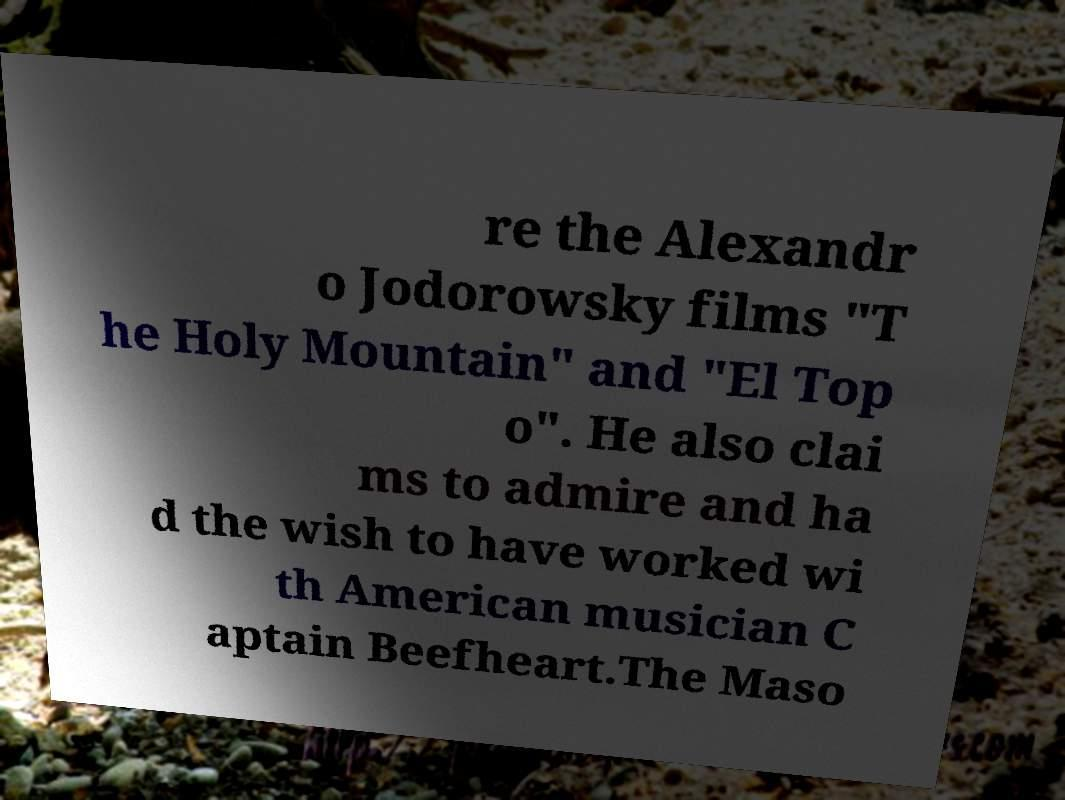Could you assist in decoding the text presented in this image and type it out clearly? re the Alexandr o Jodorowsky films "T he Holy Mountain" and "El Top o". He also clai ms to admire and ha d the wish to have worked wi th American musician C aptain Beefheart.The Maso 